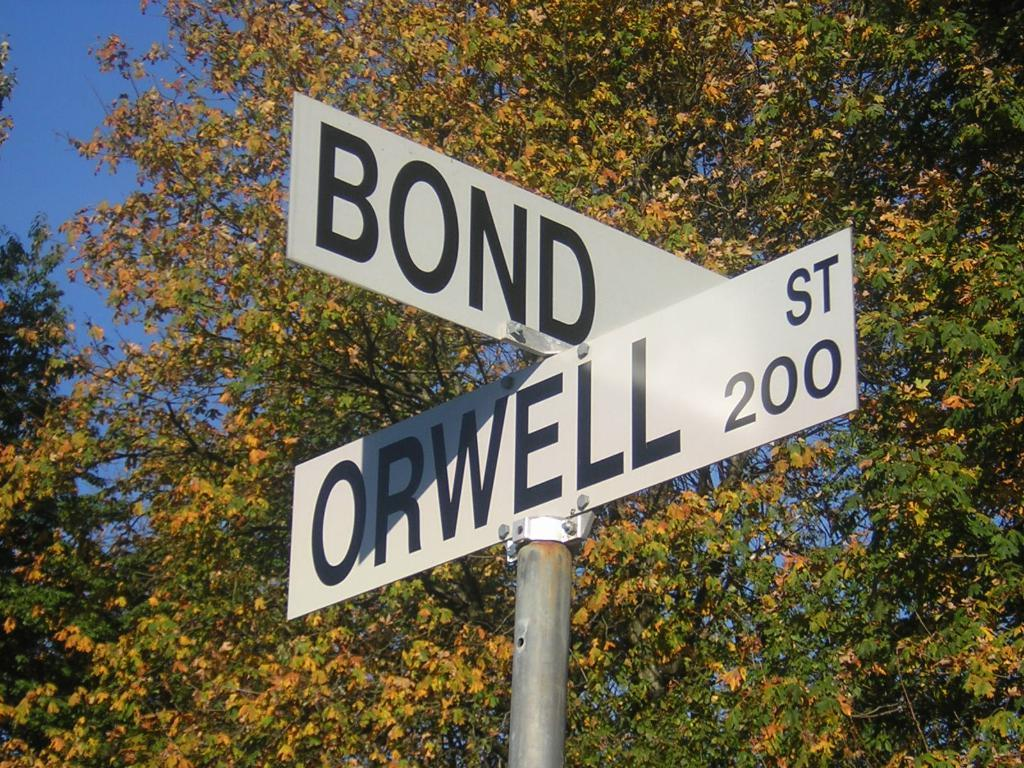What is the main object in the image? There is a pole in the image. What is written or displayed on the pole? There are boards with text and numbers on the pole. What can be seen in the background of the image? There are trees in the background of the image. Can you see a baby touching the pole in the image? There is no baby present in the image, and therefore no one is touching the pole. 